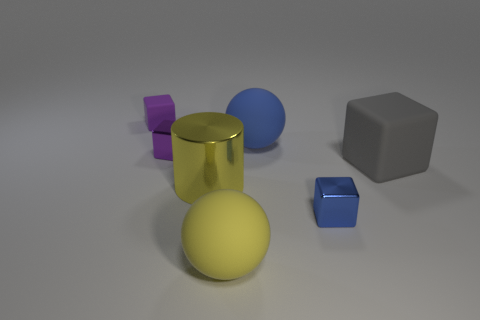There is a blue object in front of the big yellow cylinder; is its size the same as the rubber block in front of the purple rubber object?
Make the answer very short. No. What number of things are either large matte things that are behind the small blue metal block or purple metallic cylinders?
Your answer should be compact. 2. What is the large gray object made of?
Ensure brevity in your answer.  Rubber. Do the metal cylinder and the blue block have the same size?
Offer a terse response. No. How many balls are either yellow rubber objects or large gray rubber objects?
Your response must be concise. 1. What color is the matte block to the right of the tiny purple cube behind the big blue ball?
Ensure brevity in your answer.  Gray. Is the number of purple matte objects in front of the large yellow shiny cylinder less than the number of matte things to the left of the tiny blue metallic thing?
Ensure brevity in your answer.  Yes. Is the size of the gray thing the same as the block that is in front of the large yellow cylinder?
Keep it short and to the point. No. There is a large rubber object that is both left of the blue metal thing and behind the yellow metal cylinder; what is its shape?
Keep it short and to the point. Sphere. The blue object that is the same material as the big gray object is what size?
Make the answer very short. Large. 